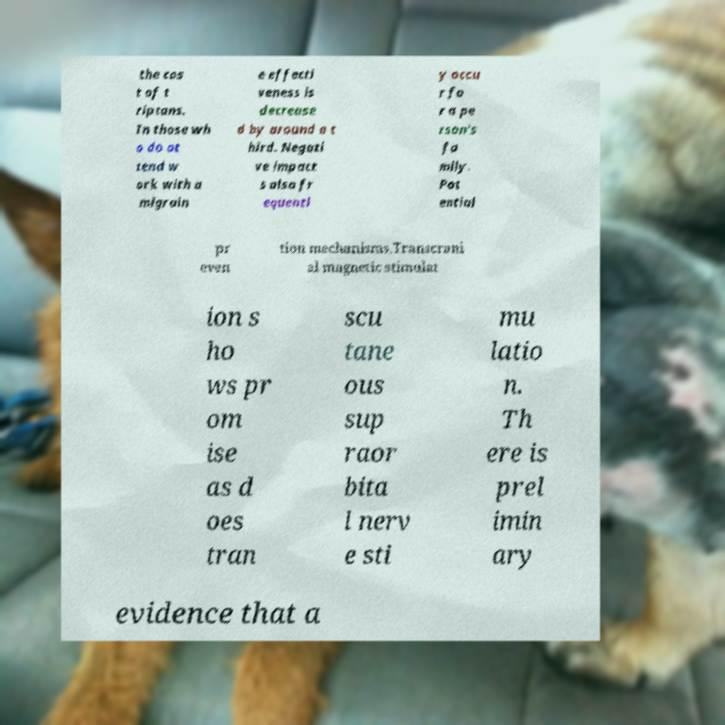Can you read and provide the text displayed in the image?This photo seems to have some interesting text. Can you extract and type it out for me? the cos t of t riptans. In those wh o do at tend w ork with a migrain e effecti veness is decrease d by around a t hird. Negati ve impact s also fr equentl y occu r fo r a pe rson's fa mily. Pot ential pr even tion mechanisms.Transcrani al magnetic stimulat ion s ho ws pr om ise as d oes tran scu tane ous sup raor bita l nerv e sti mu latio n. Th ere is prel imin ary evidence that a 